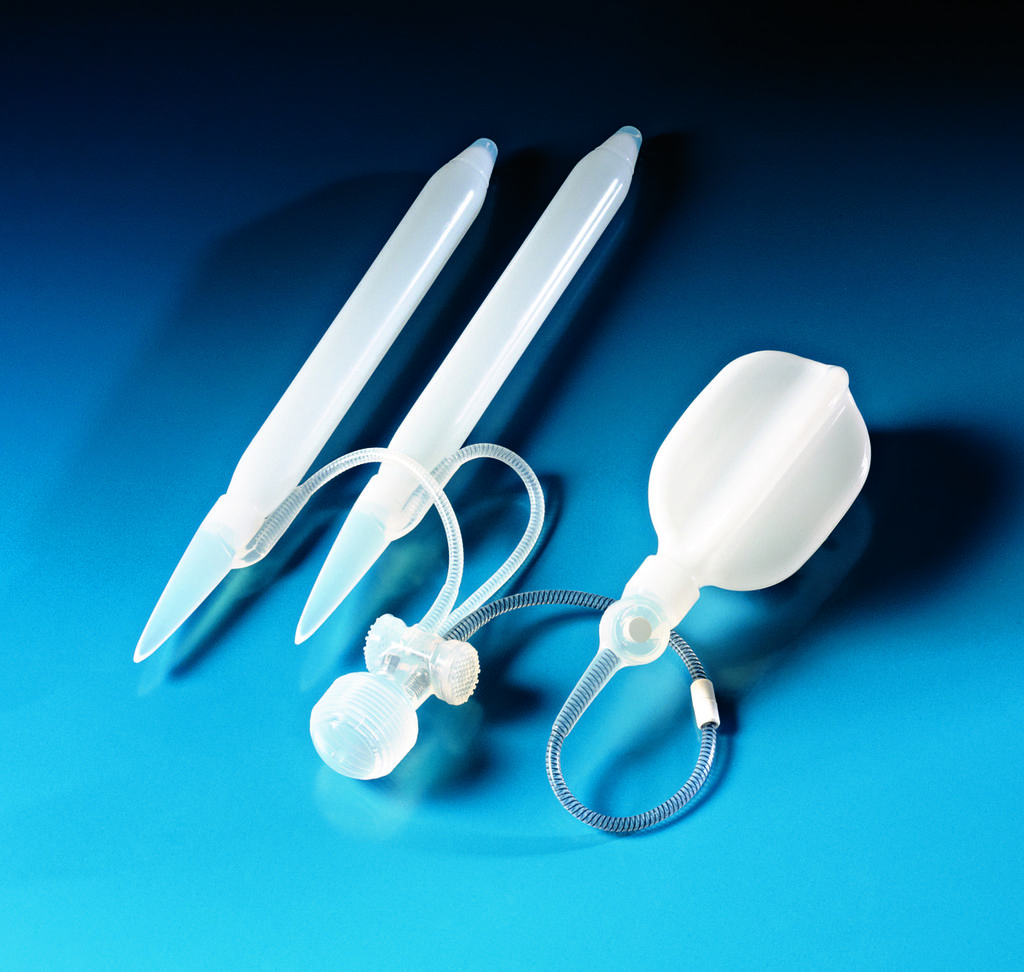What type of machine equipment is visible in the image? There is a plastic machine equipment in the image. Are there any additional features associated with the machine equipment? Yes, there are wires in the image. How many crows are sitting on the twig in the image? There are no crows or twigs present in the image. What type of frog can be seen hopping near the machine equipment in the image? There are no frogs present in the image. 